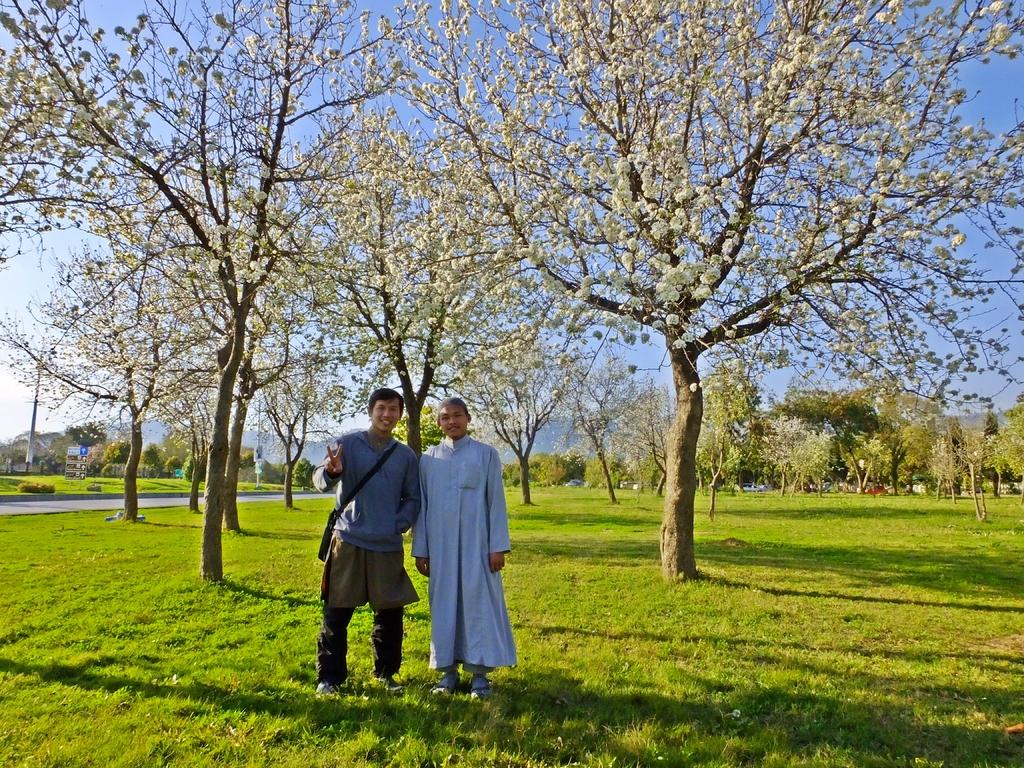How many people are in the image? There are two people standing in the center of the image. What is at the bottom of the image? There is grass at the bottom of the image. What can be seen in the background of the image? There are trees, hills, and the sky visible in the background of the image. What objects are present in the image? There are boards present in the image. What type of organization is responsible for the shocking orange color in the image? There is no organization or orange color present in the image. 